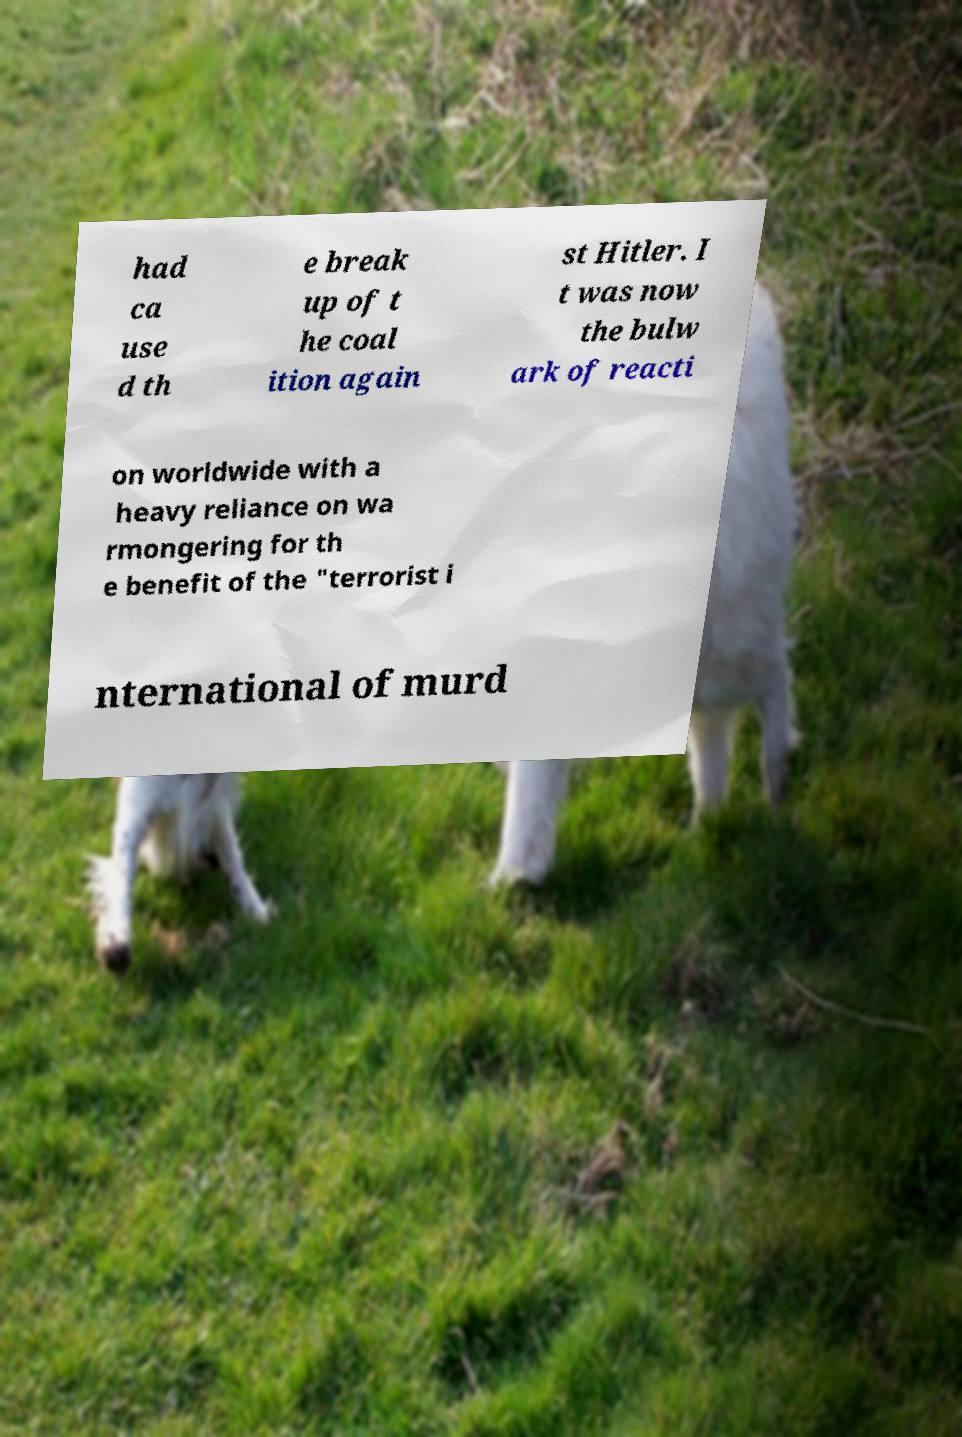Please identify and transcribe the text found in this image. had ca use d th e break up of t he coal ition again st Hitler. I t was now the bulw ark of reacti on worldwide with a heavy reliance on wa rmongering for th e benefit of the "terrorist i nternational of murd 